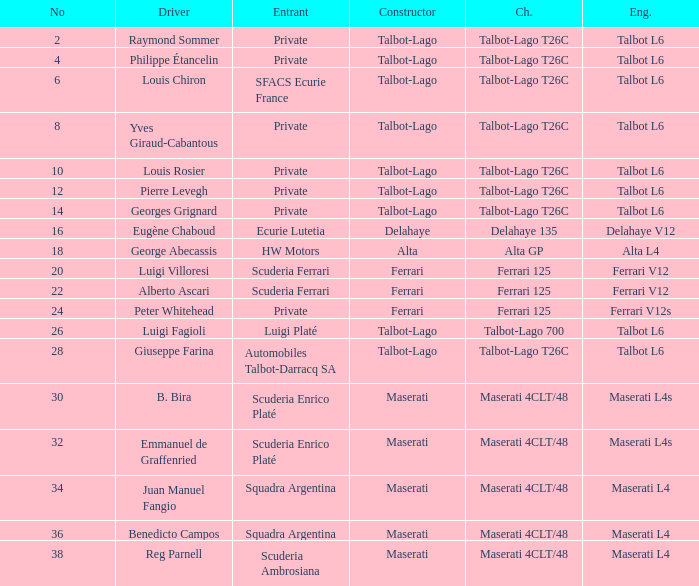Name the chassis for sfacs ecurie france Talbot-Lago T26C. 